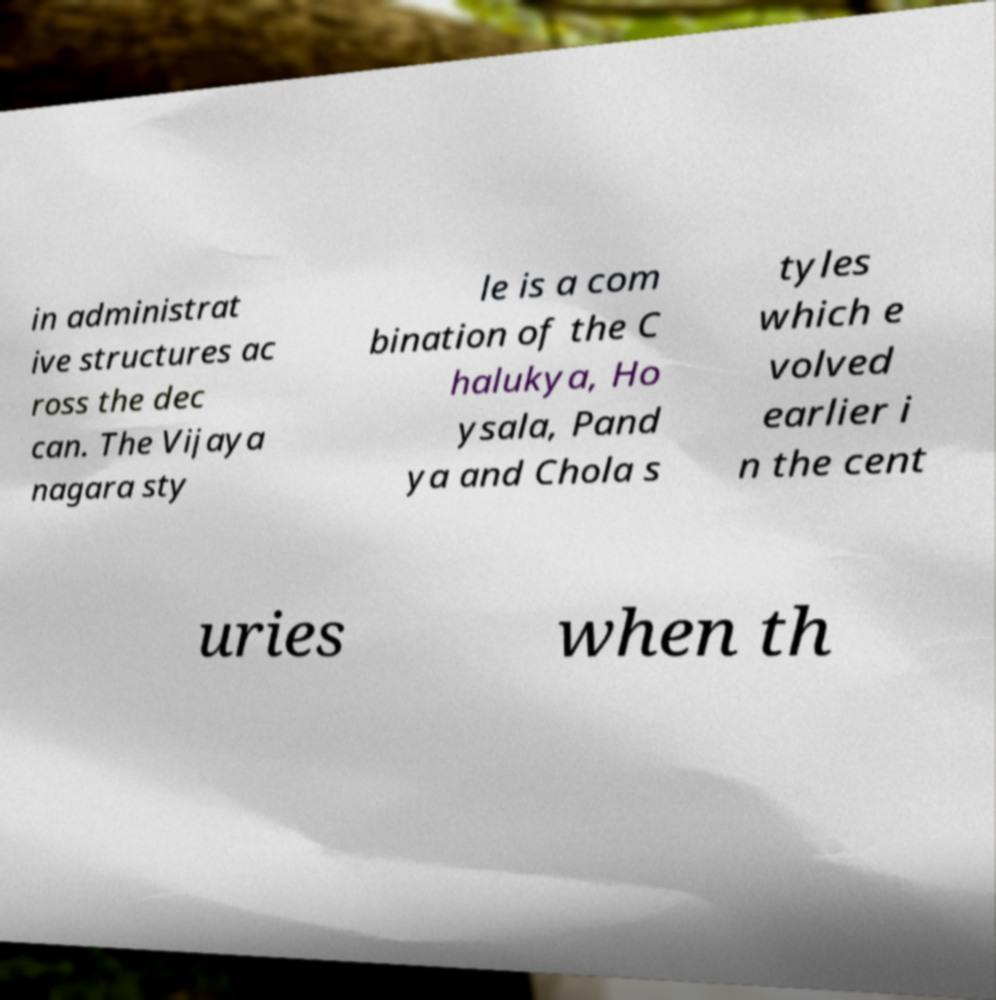Could you assist in decoding the text presented in this image and type it out clearly? in administrat ive structures ac ross the dec can. The Vijaya nagara sty le is a com bination of the C halukya, Ho ysala, Pand ya and Chola s tyles which e volved earlier i n the cent uries when th 